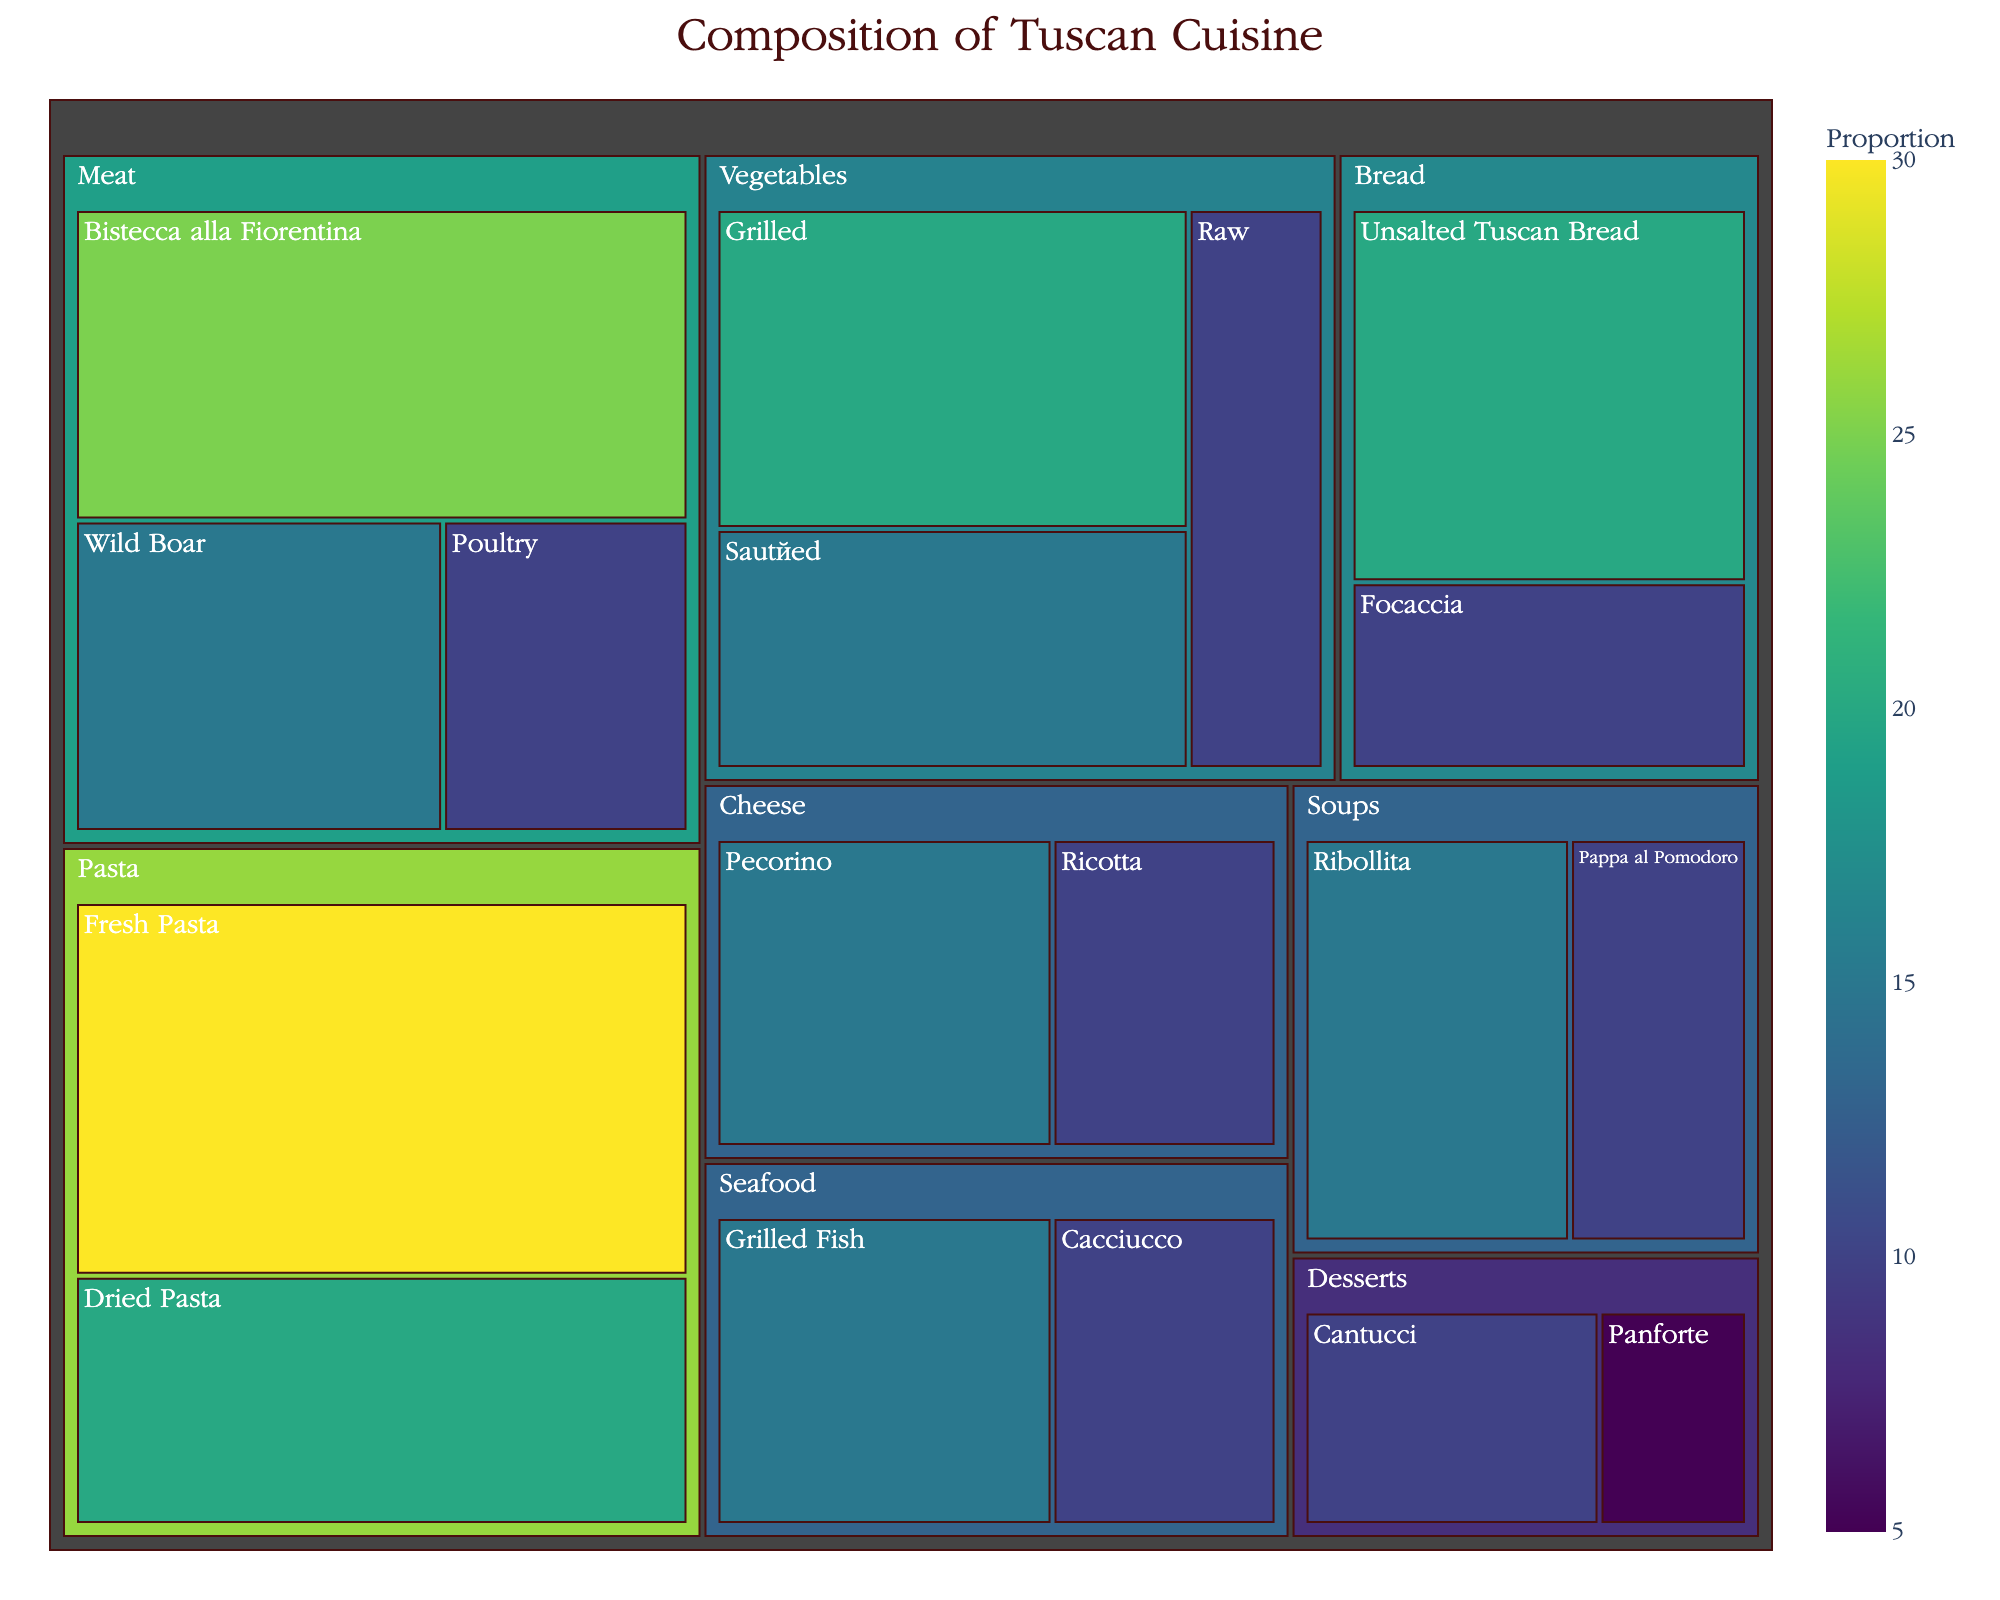what is the title of the treemap? The title can be seen at the top of the treemap. It is prominently displayed and provides an overview of what the chart is depicting.
Answer: Composition of Tuscan Cuisine What main ingredient has the highest proportion? To determine this, identify the category with the largest value. In this case, we compare all categories and see which one has the largest number assigned to it.
Answer: Pasta (Fresh Pasta) How many subcategories does the 'Meat' category have? Look at the tiles under the 'Meat' category and count the distinct subcategory labels within it.
Answer: 3 Which cooking method under 'Vegetables' has the lowest proportion? Look at the subcategories under 'Vegetables' and compare their values. Identify the one with the smallest number.
Answer: Raw What is the total proportion of the 'Soups' category? Add the values of all subcategories under 'Soups': Ribollita and Pappa al Pomodoro. First, note their values, then sum them up: 15 (Ribollita) + 10 (Pappa al Pomodoro) = 25
Answer: 25 Which category has the smallest amount under 'Desserts'? Identify the subcategories under 'Desserts' and compare their values to find the smallest one.
Answer: Panforte Is 'Cheese' or 'Seafood' more represented in the treemap? Compare the total values for the 'Cheese' and 'Seafood' categories. Cheese: Pecorino (15) + Ricotta (10) = 25. Seafood: Grilled Fish (15) + Cacciucco (10) = 25. Both have the same representation.
Answer: Equal What is the median value of the subcategories under 'Pasta'? List the values under 'Pasta' (Fresh Pasta, Dried Pasta), sort them, and find the middle value(s). Since there are two values (30, 20), the median is the average of these: (30 + 20) / 2 = 25
Answer: 25 What's the difference in proportion between 'Grilled Fish' under 'Seafood' and 'Wild Boar' under 'Meat'? Find the values for 'Grilled Fish' (15) and 'Wild Boar' (15), then calculate the difference: 15 - 15 = 0
Answer: 0 